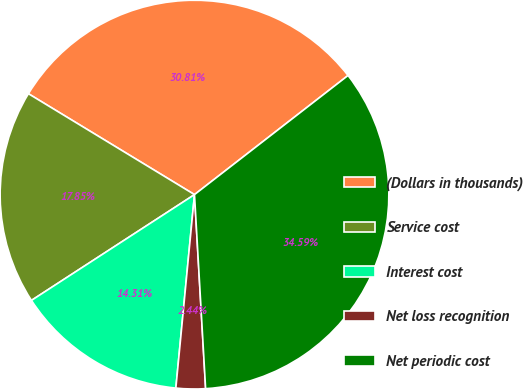Convert chart. <chart><loc_0><loc_0><loc_500><loc_500><pie_chart><fcel>(Dollars in thousands)<fcel>Service cost<fcel>Interest cost<fcel>Net loss recognition<fcel>Net periodic cost<nl><fcel>30.81%<fcel>17.85%<fcel>14.31%<fcel>2.44%<fcel>34.59%<nl></chart> 